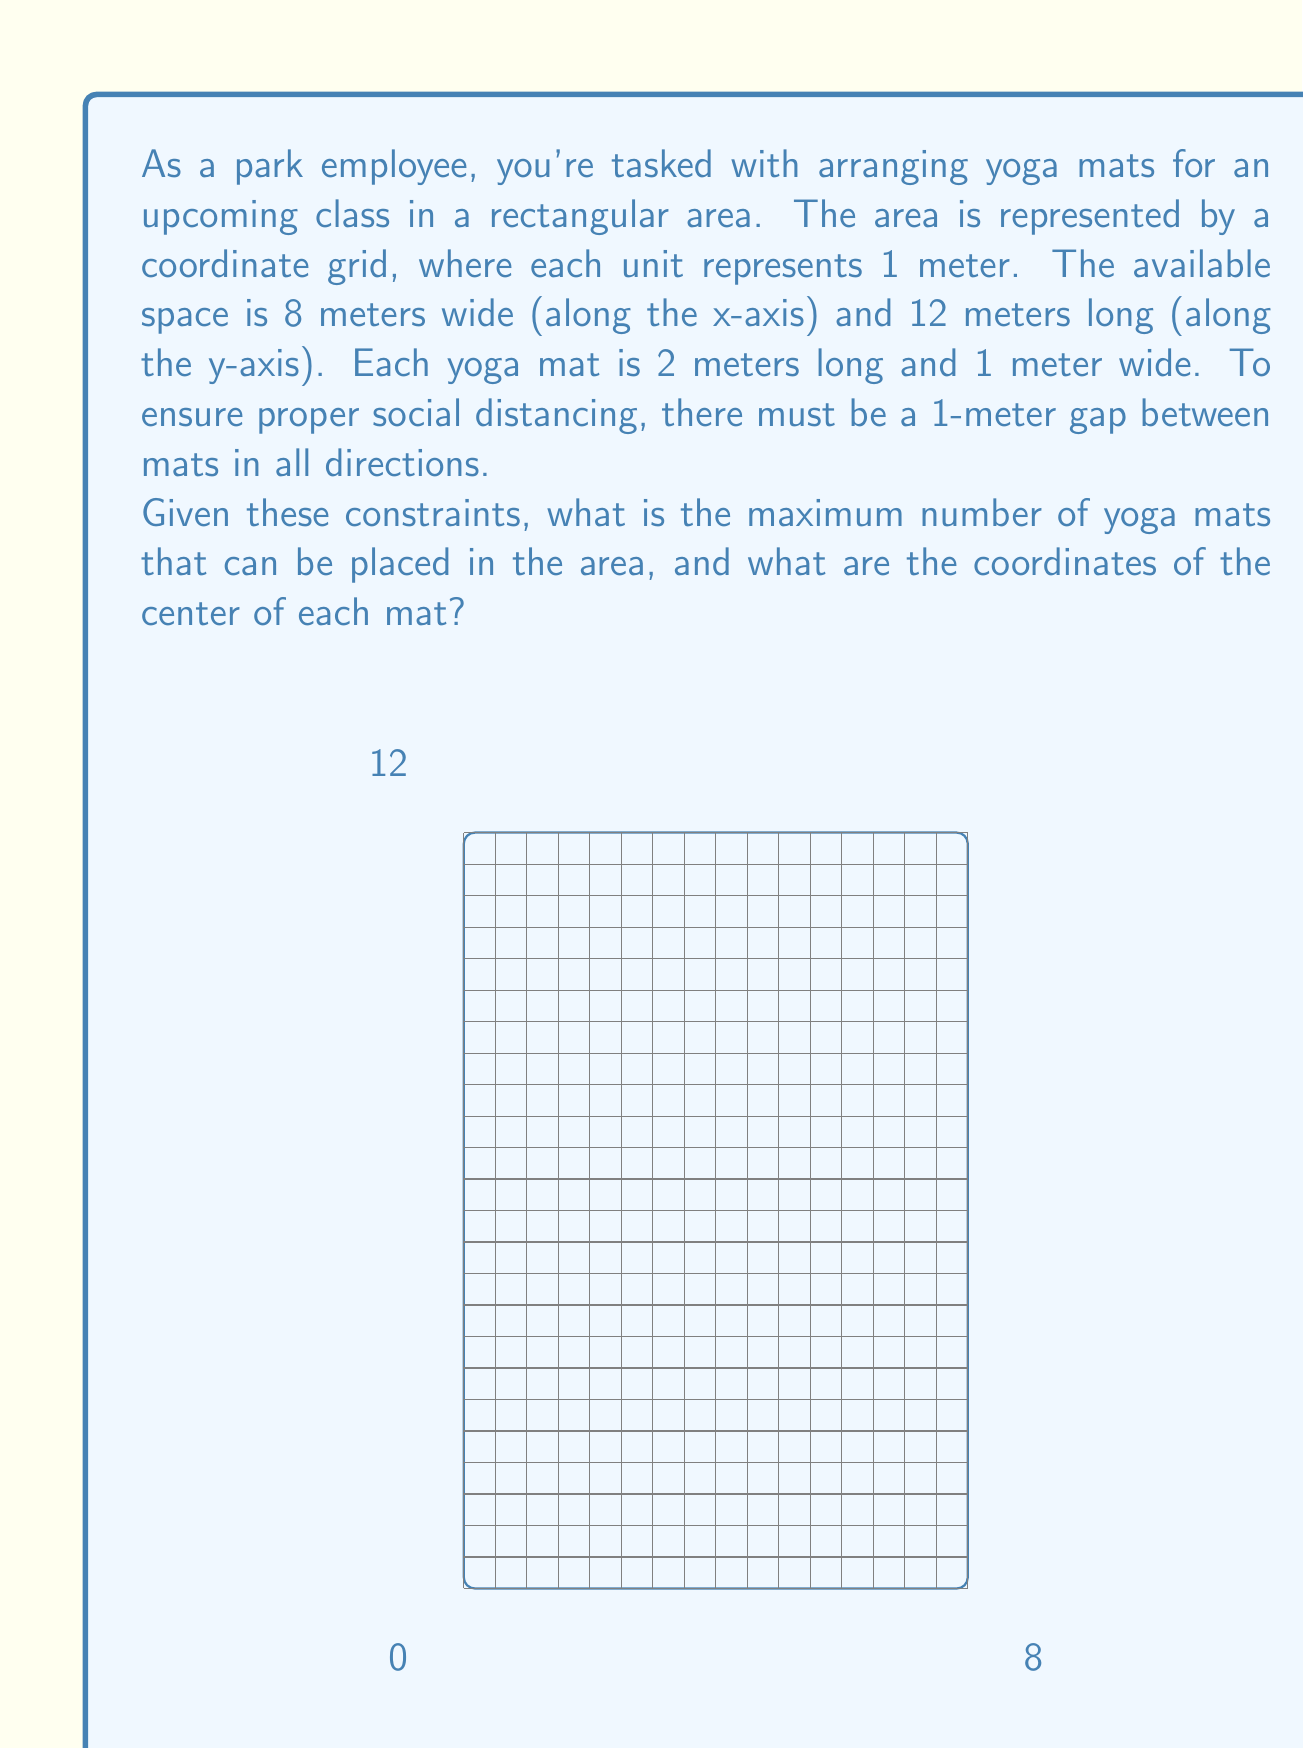Could you help me with this problem? Let's approach this step-by-step:

1) First, we need to determine how many mats can fit along each axis:

   x-axis: The width of the area is 8 meters.
   Each mat takes up 1 meter width + 1 meter gap = 2 meters total.
   Number of mats along x-axis = $\lfloor \frac{8}{2} \rfloor = 4$

   y-axis: The length of the area is 12 meters.
   Each mat takes up 2 meters length + 1 meter gap = 3 meters total.
   Number of mats along y-axis = $\lfloor \frac{12}{3} \rfloor = 4$

2) The total number of mats is therefore $4 \times 4 = 16$.

3) Now, let's determine the coordinates of the center of each mat:

   Along the x-axis:
   - The first mat's center will be at x = 1 (0.5 meter from the edge + 0.5 meter to the center)
   - Each subsequent mat will be 2 meters apart
   - So the x-coordinates will be 1, 3, 5, and 7

   Along the y-axis:
   - The first mat's center will be at y = 1.5 (0.5 meter from the edge + 1 meter to the center)
   - Each subsequent mat will be 3 meters apart
   - So the y-coordinates will be 1.5, 4.5, 7.5, and 10.5

4) The coordinates of the centers of all mats will be:
   $$(1, 1.5), (3, 1.5), (5, 1.5), (7, 1.5)$$
   $$(1, 4.5), (3, 4.5), (5, 4.5), (7, 4.5)$$
   $$(1, 7.5), (3, 7.5), (5, 7.5), (7, 7.5)$$
   $$(1, 10.5), (3, 10.5), (5, 10.5), (7, 10.5)$$
Answer: The maximum number of yoga mats that can be placed is 16. The coordinates of the center of each mat are:
$$(1, 1.5), (3, 1.5), (5, 1.5), (7, 1.5)$$
$$(1, 4.5), (3, 4.5), (5, 4.5), (7, 4.5)$$
$$(1, 7.5), (3, 7.5), (5, 7.5), (7, 7.5)$$
$$(1, 10.5), (3, 10.5), (5, 10.5), (7, 10.5)$$ 